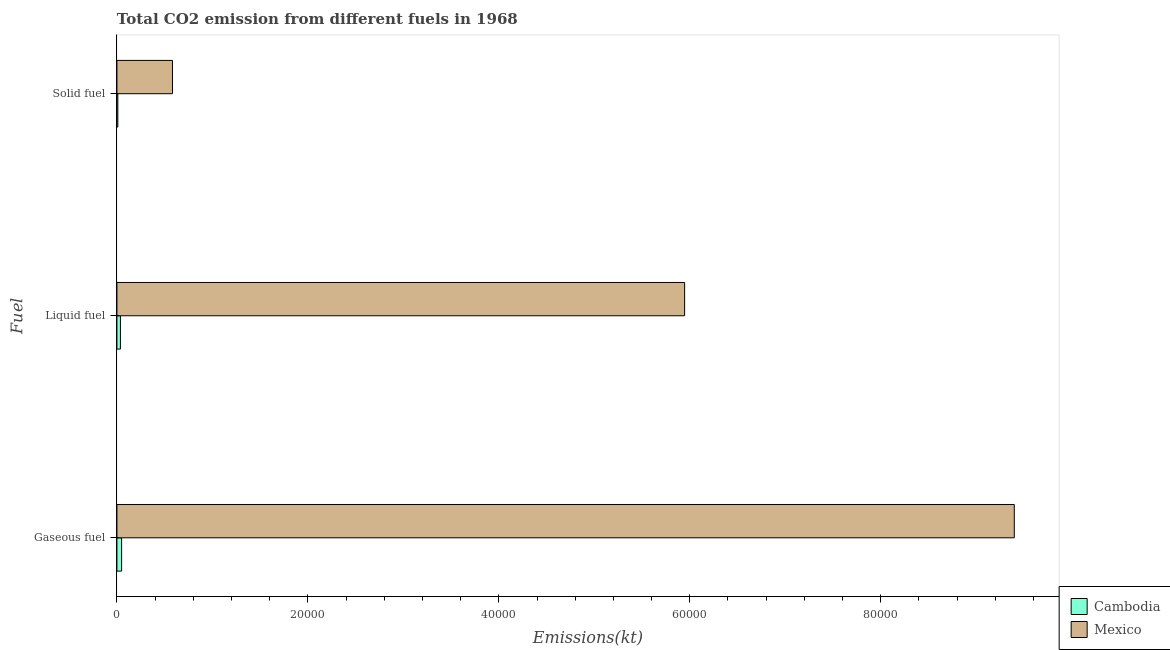How many bars are there on the 2nd tick from the top?
Offer a very short reply. 2. What is the label of the 2nd group of bars from the top?
Offer a very short reply. Liquid fuel. What is the amount of co2 emissions from gaseous fuel in Cambodia?
Give a very brief answer. 491.38. Across all countries, what is the maximum amount of co2 emissions from solid fuel?
Offer a very short reply. 5819.53. Across all countries, what is the minimum amount of co2 emissions from liquid fuel?
Provide a succinct answer. 366.7. In which country was the amount of co2 emissions from liquid fuel minimum?
Your answer should be very brief. Cambodia. What is the total amount of co2 emissions from liquid fuel in the graph?
Your answer should be very brief. 5.98e+04. What is the difference between the amount of co2 emissions from solid fuel in Cambodia and that in Mexico?
Provide a short and direct response. -5724.19. What is the difference between the amount of co2 emissions from gaseous fuel in Mexico and the amount of co2 emissions from liquid fuel in Cambodia?
Make the answer very short. 9.36e+04. What is the average amount of co2 emissions from liquid fuel per country?
Ensure brevity in your answer.  2.99e+04. What is the difference between the amount of co2 emissions from solid fuel and amount of co2 emissions from gaseous fuel in Cambodia?
Provide a succinct answer. -396.04. What is the ratio of the amount of co2 emissions from liquid fuel in Cambodia to that in Mexico?
Make the answer very short. 0.01. Is the amount of co2 emissions from gaseous fuel in Cambodia less than that in Mexico?
Your answer should be very brief. Yes. What is the difference between the highest and the second highest amount of co2 emissions from liquid fuel?
Your response must be concise. 5.91e+04. What is the difference between the highest and the lowest amount of co2 emissions from liquid fuel?
Keep it short and to the point. 5.91e+04. Is the sum of the amount of co2 emissions from solid fuel in Mexico and Cambodia greater than the maximum amount of co2 emissions from gaseous fuel across all countries?
Provide a short and direct response. No. What does the 1st bar from the top in Liquid fuel represents?
Ensure brevity in your answer.  Mexico. Is it the case that in every country, the sum of the amount of co2 emissions from gaseous fuel and amount of co2 emissions from liquid fuel is greater than the amount of co2 emissions from solid fuel?
Provide a succinct answer. Yes. Are all the bars in the graph horizontal?
Offer a terse response. Yes. Are the values on the major ticks of X-axis written in scientific E-notation?
Make the answer very short. No. Where does the legend appear in the graph?
Your response must be concise. Bottom right. How many legend labels are there?
Your response must be concise. 2. What is the title of the graph?
Offer a terse response. Total CO2 emission from different fuels in 1968. Does "Malawi" appear as one of the legend labels in the graph?
Provide a succinct answer. No. What is the label or title of the X-axis?
Keep it short and to the point. Emissions(kt). What is the label or title of the Y-axis?
Make the answer very short. Fuel. What is the Emissions(kt) in Cambodia in Gaseous fuel?
Keep it short and to the point. 491.38. What is the Emissions(kt) in Mexico in Gaseous fuel?
Your answer should be compact. 9.40e+04. What is the Emissions(kt) of Cambodia in Liquid fuel?
Provide a succinct answer. 366.7. What is the Emissions(kt) in Mexico in Liquid fuel?
Keep it short and to the point. 5.95e+04. What is the Emissions(kt) of Cambodia in Solid fuel?
Offer a terse response. 95.34. What is the Emissions(kt) in Mexico in Solid fuel?
Offer a terse response. 5819.53. Across all Fuel, what is the maximum Emissions(kt) of Cambodia?
Offer a terse response. 491.38. Across all Fuel, what is the maximum Emissions(kt) in Mexico?
Provide a succinct answer. 9.40e+04. Across all Fuel, what is the minimum Emissions(kt) in Cambodia?
Your answer should be very brief. 95.34. Across all Fuel, what is the minimum Emissions(kt) of Mexico?
Keep it short and to the point. 5819.53. What is the total Emissions(kt) in Cambodia in the graph?
Provide a short and direct response. 953.42. What is the total Emissions(kt) of Mexico in the graph?
Your response must be concise. 1.59e+05. What is the difference between the Emissions(kt) of Cambodia in Gaseous fuel and that in Liquid fuel?
Ensure brevity in your answer.  124.68. What is the difference between the Emissions(kt) of Mexico in Gaseous fuel and that in Liquid fuel?
Make the answer very short. 3.45e+04. What is the difference between the Emissions(kt) of Cambodia in Gaseous fuel and that in Solid fuel?
Keep it short and to the point. 396.04. What is the difference between the Emissions(kt) of Mexico in Gaseous fuel and that in Solid fuel?
Provide a succinct answer. 8.82e+04. What is the difference between the Emissions(kt) in Cambodia in Liquid fuel and that in Solid fuel?
Your response must be concise. 271.36. What is the difference between the Emissions(kt) in Mexico in Liquid fuel and that in Solid fuel?
Your answer should be compact. 5.36e+04. What is the difference between the Emissions(kt) of Cambodia in Gaseous fuel and the Emissions(kt) of Mexico in Liquid fuel?
Offer a terse response. -5.90e+04. What is the difference between the Emissions(kt) in Cambodia in Gaseous fuel and the Emissions(kt) in Mexico in Solid fuel?
Your answer should be compact. -5328.15. What is the difference between the Emissions(kt) in Cambodia in Liquid fuel and the Emissions(kt) in Mexico in Solid fuel?
Your answer should be very brief. -5452.83. What is the average Emissions(kt) in Cambodia per Fuel?
Give a very brief answer. 317.81. What is the average Emissions(kt) in Mexico per Fuel?
Your response must be concise. 5.31e+04. What is the difference between the Emissions(kt) of Cambodia and Emissions(kt) of Mexico in Gaseous fuel?
Your answer should be compact. -9.35e+04. What is the difference between the Emissions(kt) of Cambodia and Emissions(kt) of Mexico in Liquid fuel?
Your answer should be compact. -5.91e+04. What is the difference between the Emissions(kt) in Cambodia and Emissions(kt) in Mexico in Solid fuel?
Offer a very short reply. -5724.19. What is the ratio of the Emissions(kt) of Cambodia in Gaseous fuel to that in Liquid fuel?
Offer a terse response. 1.34. What is the ratio of the Emissions(kt) of Mexico in Gaseous fuel to that in Liquid fuel?
Your answer should be compact. 1.58. What is the ratio of the Emissions(kt) of Cambodia in Gaseous fuel to that in Solid fuel?
Give a very brief answer. 5.15. What is the ratio of the Emissions(kt) of Mexico in Gaseous fuel to that in Solid fuel?
Provide a succinct answer. 16.15. What is the ratio of the Emissions(kt) of Cambodia in Liquid fuel to that in Solid fuel?
Give a very brief answer. 3.85. What is the ratio of the Emissions(kt) in Mexico in Liquid fuel to that in Solid fuel?
Provide a short and direct response. 10.22. What is the difference between the highest and the second highest Emissions(kt) of Cambodia?
Keep it short and to the point. 124.68. What is the difference between the highest and the second highest Emissions(kt) of Mexico?
Keep it short and to the point. 3.45e+04. What is the difference between the highest and the lowest Emissions(kt) in Cambodia?
Make the answer very short. 396.04. What is the difference between the highest and the lowest Emissions(kt) of Mexico?
Provide a short and direct response. 8.82e+04. 